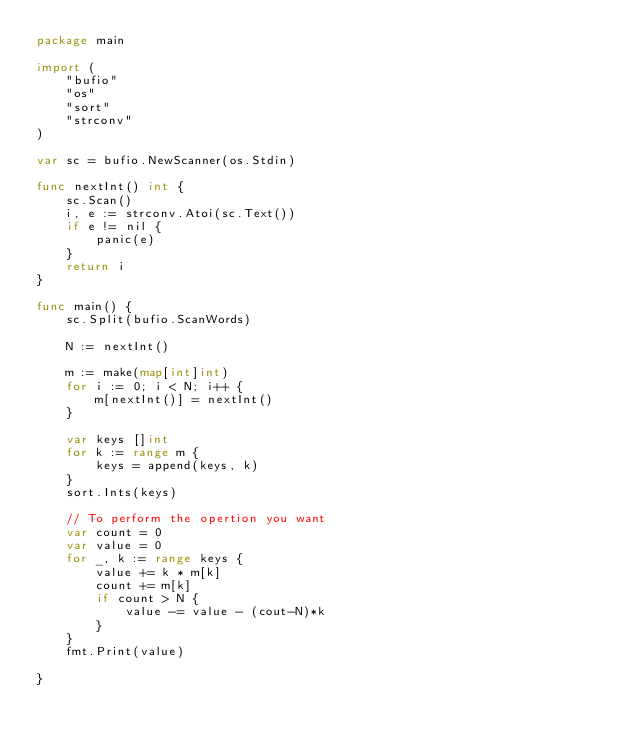Convert code to text. <code><loc_0><loc_0><loc_500><loc_500><_Go_>package main

import (
	"bufio"
	"os"
	"sort"
	"strconv"
)

var sc = bufio.NewScanner(os.Stdin)

func nextInt() int {
	sc.Scan()
	i, e := strconv.Atoi(sc.Text())
	if e != nil {
		panic(e)
	}
	return i
}

func main() {
	sc.Split(bufio.ScanWords)

	N := nextInt()

	m := make(map[int]int)
	for i := 0; i < N; i++ {
		m[nextInt()] = nextInt()
	}

	var keys []int
	for k := range m {
		keys = append(keys, k)
	}
	sort.Ints(keys)

	// To perform the opertion you want
	var count = 0
	var value = 0
	for _, k := range keys {
		value += k * m[k]
		count += m[k]
		if count > N {
			value -= value - (cout-N)*k
		}
	}
	fmt.Print(value)

}</code> 